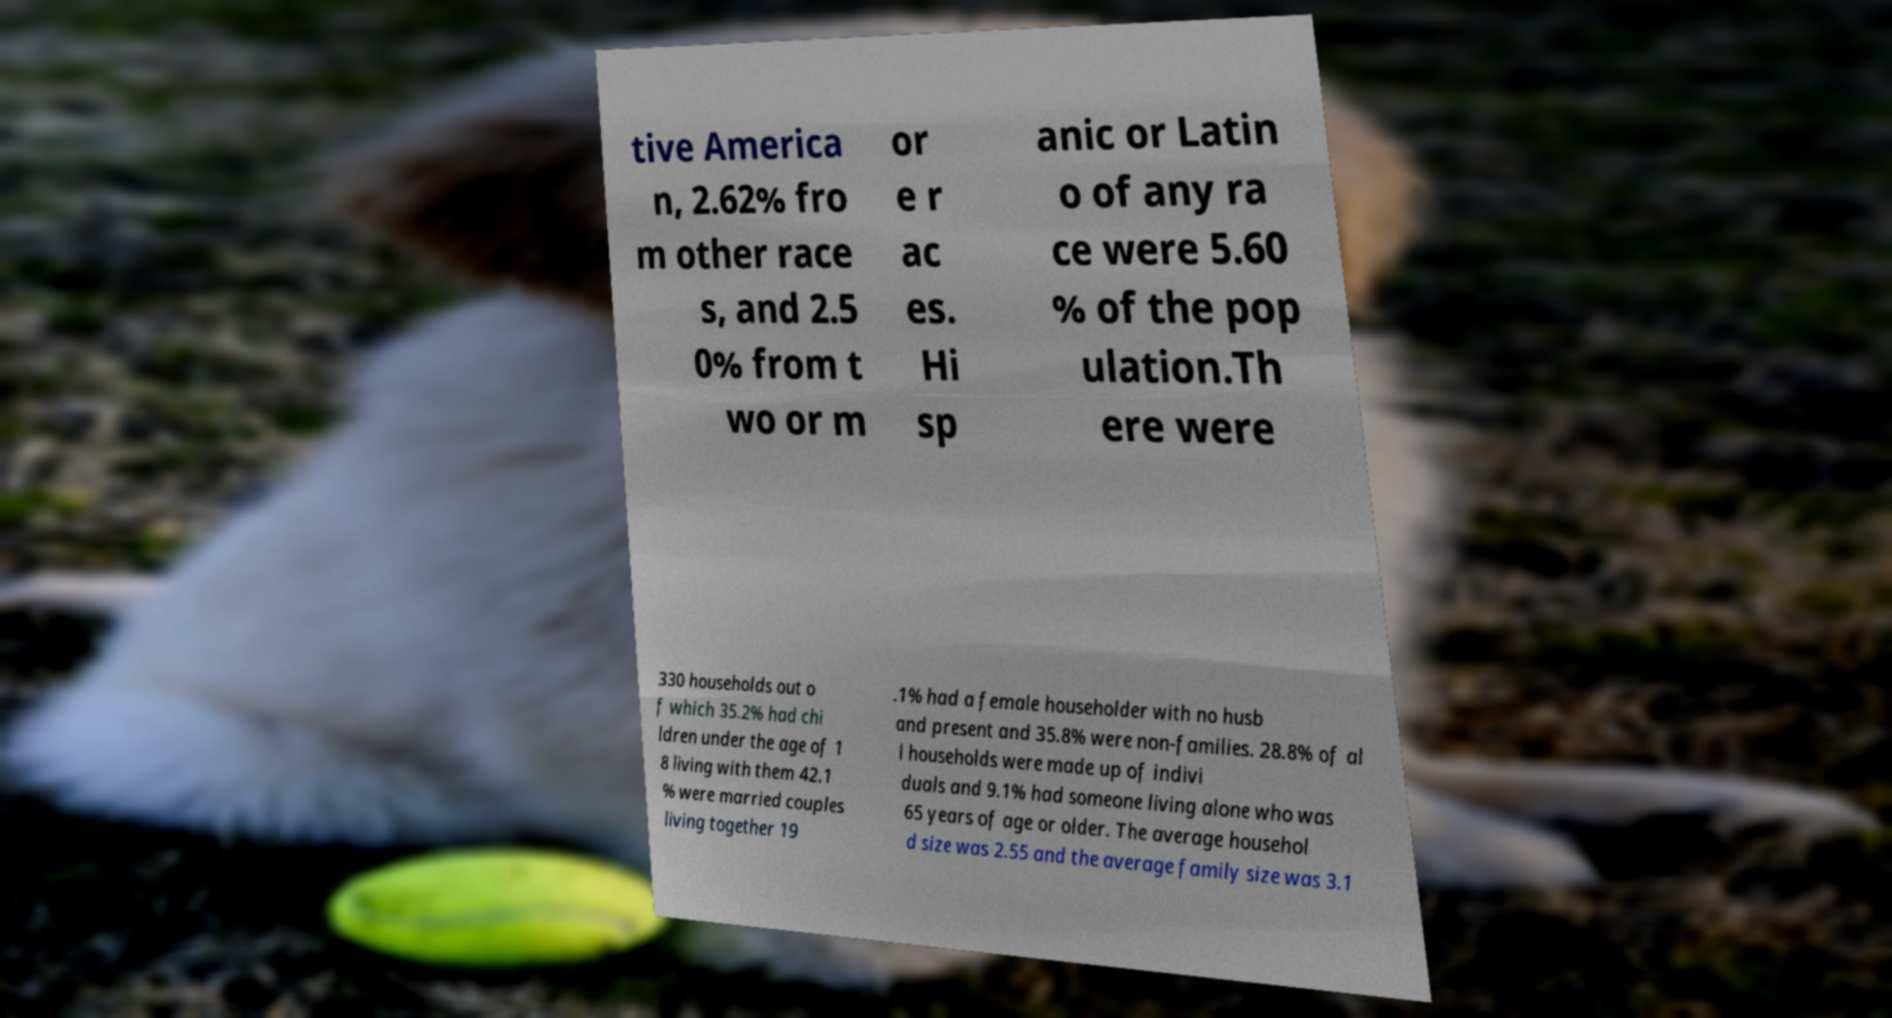Can you accurately transcribe the text from the provided image for me? tive America n, 2.62% fro m other race s, and 2.5 0% from t wo or m or e r ac es. Hi sp anic or Latin o of any ra ce were 5.60 % of the pop ulation.Th ere were 330 households out o f which 35.2% had chi ldren under the age of 1 8 living with them 42.1 % were married couples living together 19 .1% had a female householder with no husb and present and 35.8% were non-families. 28.8% of al l households were made up of indivi duals and 9.1% had someone living alone who was 65 years of age or older. The average househol d size was 2.55 and the average family size was 3.1 